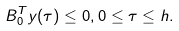<formula> <loc_0><loc_0><loc_500><loc_500>B _ { 0 } ^ { T } y ( \tau ) \leq 0 , 0 \leq \tau \leq h .</formula> 